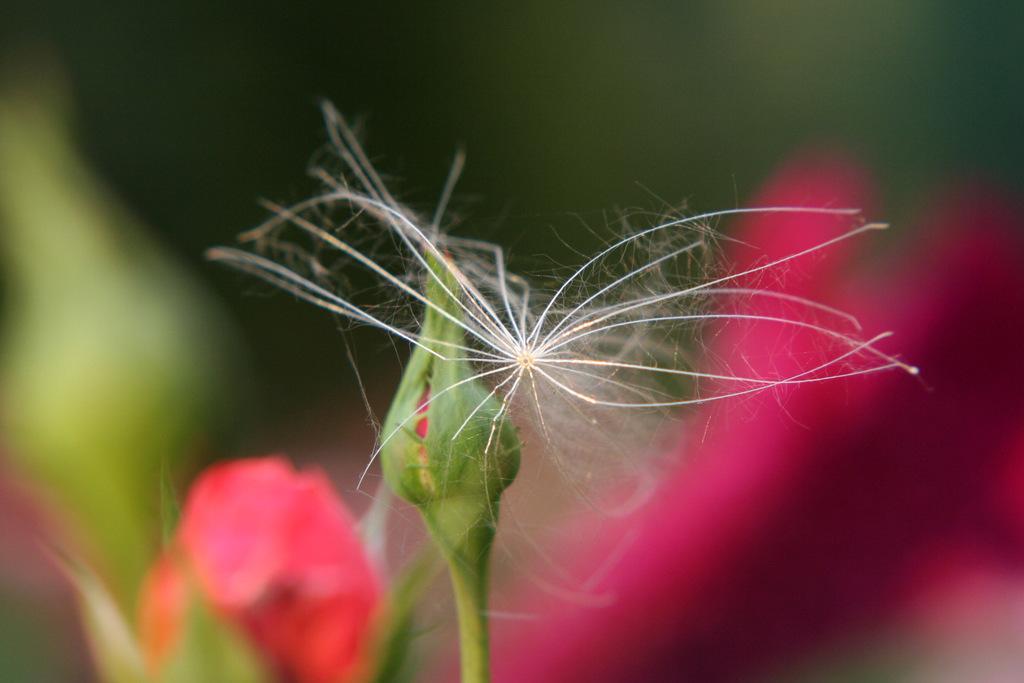How would you summarize this image in a sentence or two? In the image we can see flowers and a bud, on the bud there is an insect and background is blurred. 